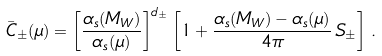Convert formula to latex. <formula><loc_0><loc_0><loc_500><loc_500>\bar { C } _ { \pm } ( \mu ) = \left [ \frac { \alpha _ { s } ( M _ { W } ) } { \alpha _ { s } ( \mu ) } \right ] ^ { d _ { \pm } } \left [ 1 + \frac { \alpha _ { s } ( M _ { W } ) - \alpha _ { s } ( \mu ) } { 4 \pi } \, S _ { \pm } \right ] \, .</formula> 